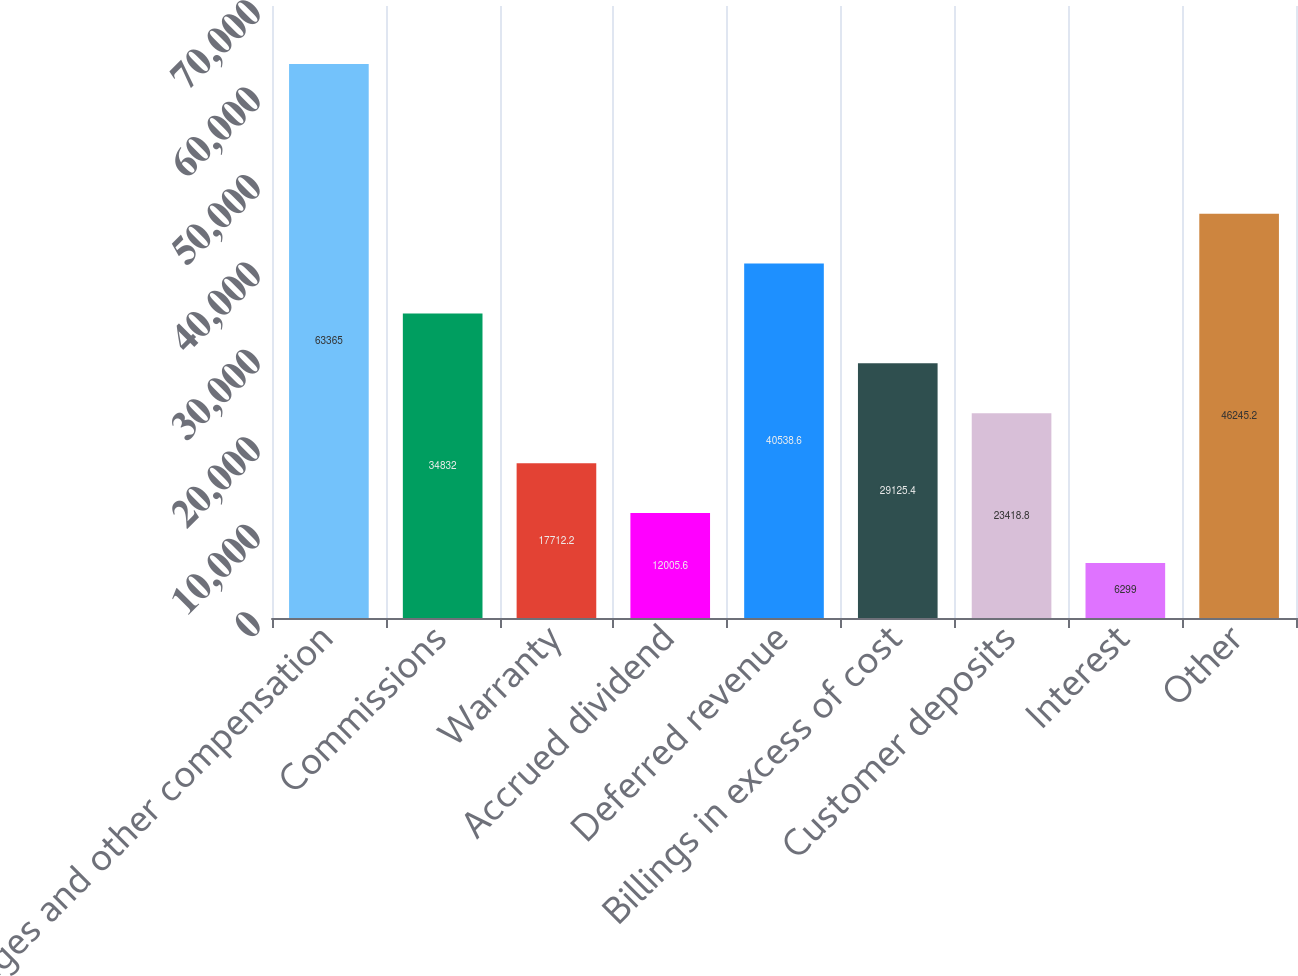Convert chart to OTSL. <chart><loc_0><loc_0><loc_500><loc_500><bar_chart><fcel>Wages and other compensation<fcel>Commissions<fcel>Warranty<fcel>Accrued dividend<fcel>Deferred revenue<fcel>Billings in excess of cost<fcel>Customer deposits<fcel>Interest<fcel>Other<nl><fcel>63365<fcel>34832<fcel>17712.2<fcel>12005.6<fcel>40538.6<fcel>29125.4<fcel>23418.8<fcel>6299<fcel>46245.2<nl></chart> 